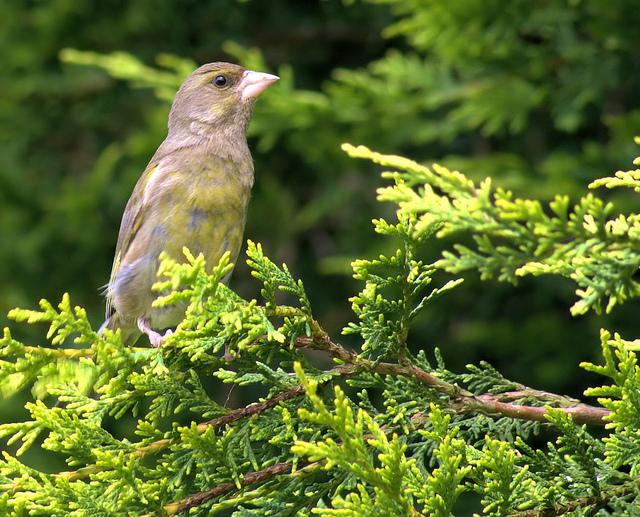What is the bird sitting on?
Write a very short answer. Branch. Which direction is the bird facing?
Give a very brief answer. Right. What kind of tree is  the bird on?
Quick response, please. Pine. Is the bird blue and gray?
Keep it brief. No. What does this bird eat?
Keep it brief. Worms. Can this bird fly?
Write a very short answer. Yes. 